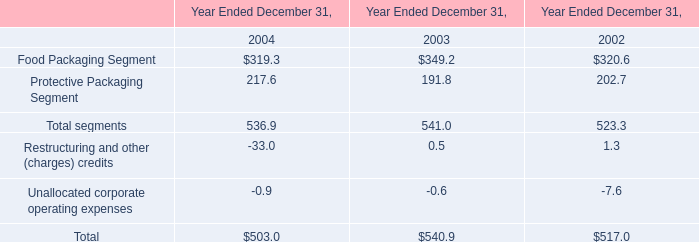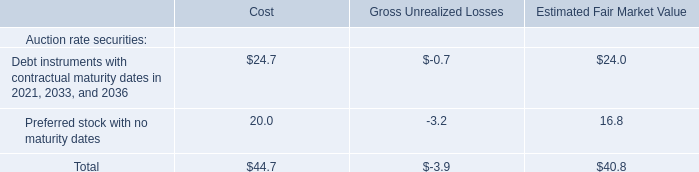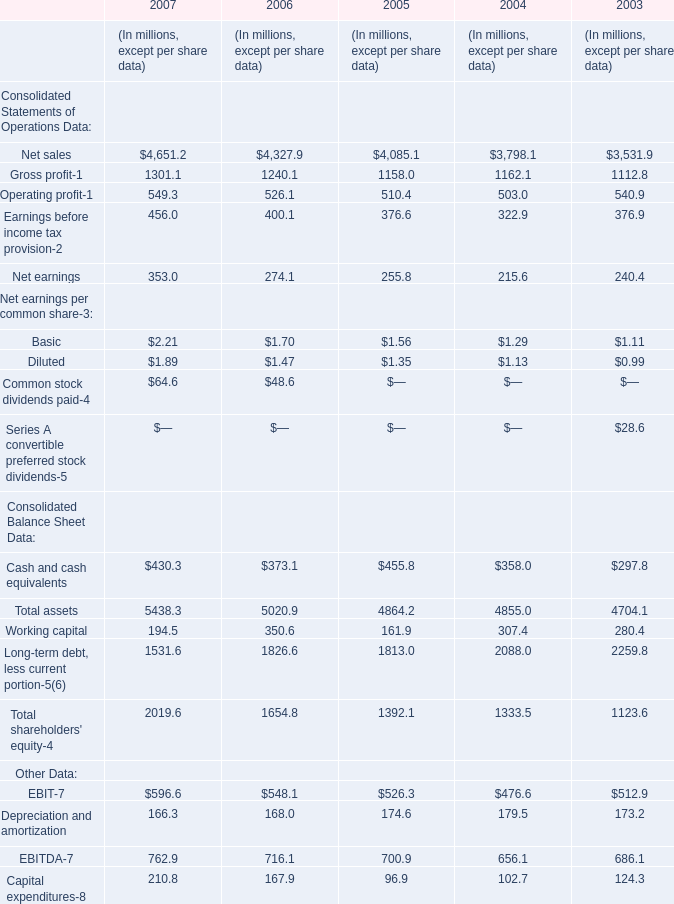What is the value of the Total assets for 2007 as As the chart 2 shows? (in million) 
Answer: 5438.3. 